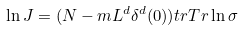Convert formula to latex. <formula><loc_0><loc_0><loc_500><loc_500>\ln J = ( N - m L ^ { d } \delta ^ { d } ( 0 ) ) t r T r \ln \sigma</formula> 